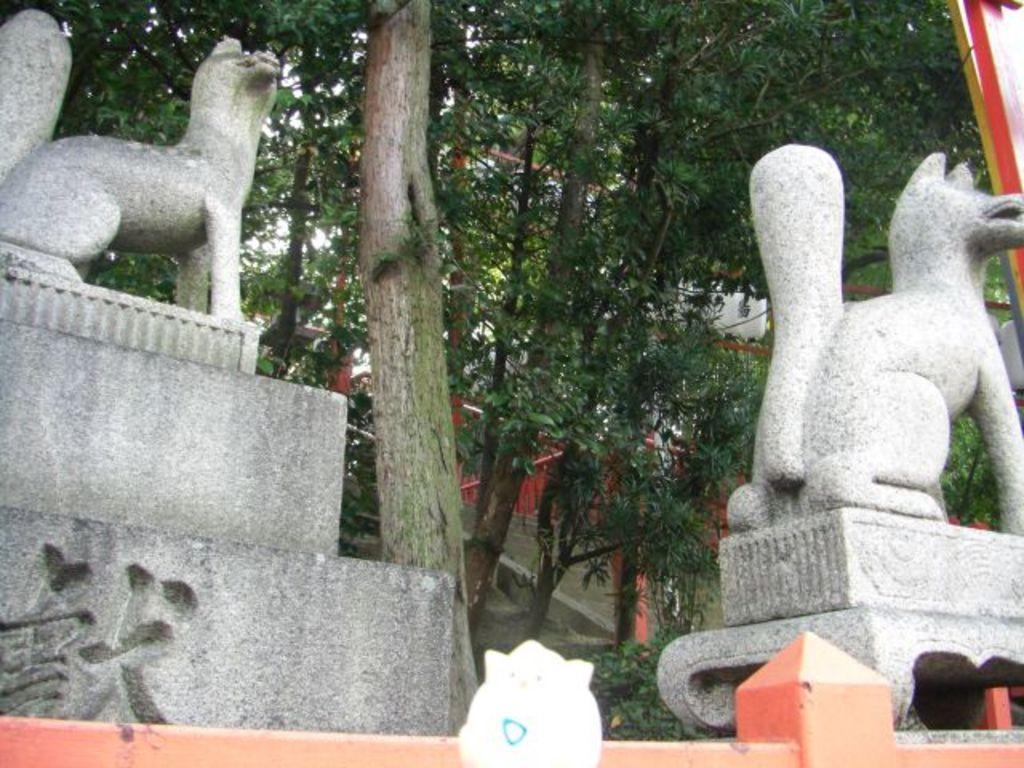Could you give a brief overview of what you see in this image? In this picture there are few statues and there are trees in the background. 